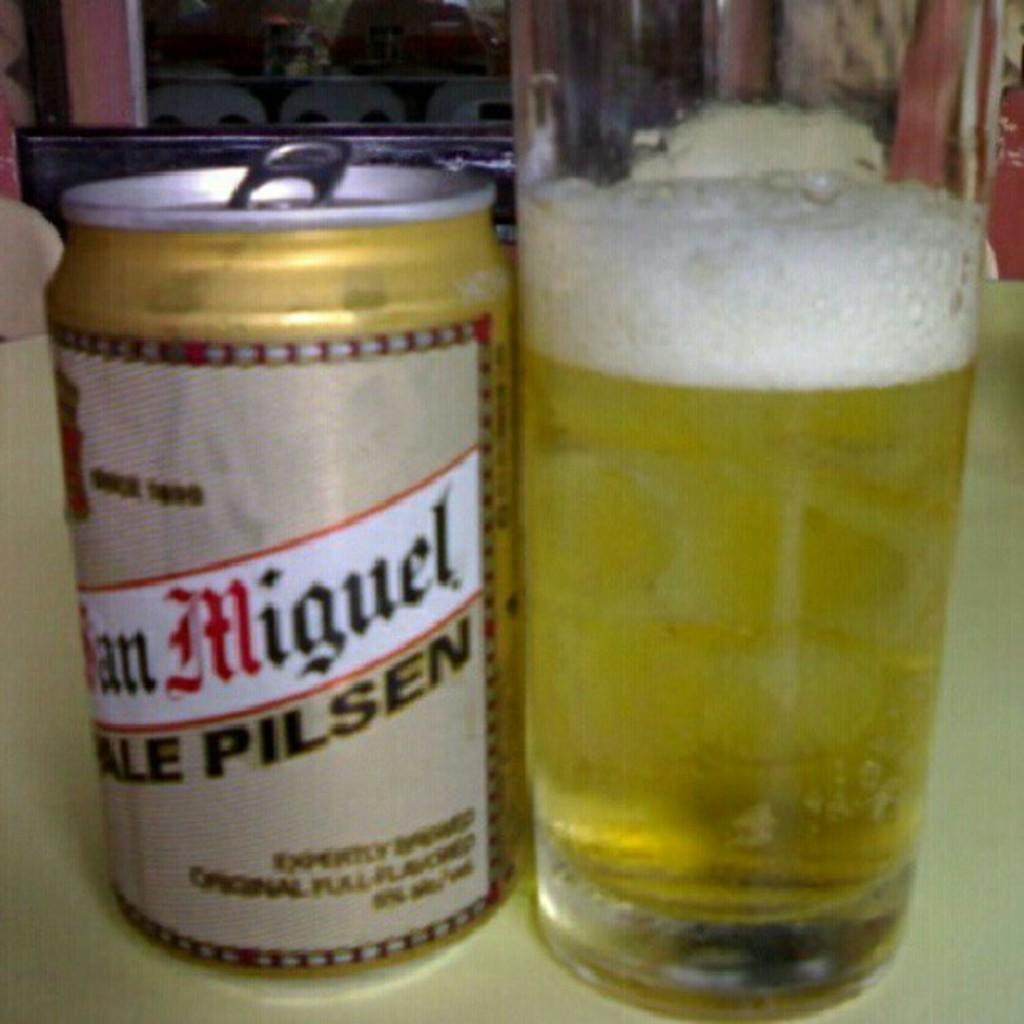Provide a one-sentence caption for the provided image. A can of Pale Pilsen beer is next to a full glass. 